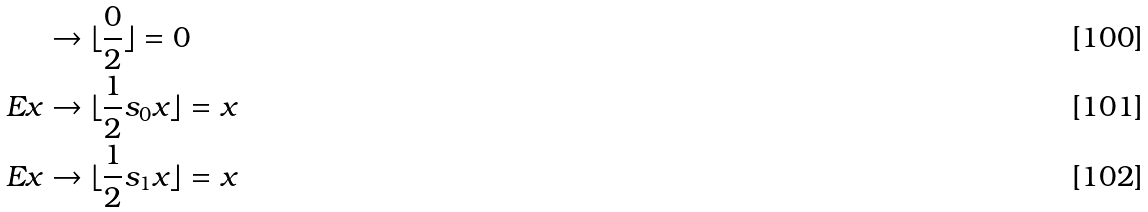Convert formula to latex. <formula><loc_0><loc_0><loc_500><loc_500>& \rightarrow \lfloor \frac { 0 } { 2 } \rfloor = 0 \\ E x & \rightarrow \lfloor \frac { 1 } { 2 } s _ { 0 } x \rfloor = x \\ E x & \rightarrow \lfloor \frac { 1 } { 2 } s _ { 1 } x \rfloor = x</formula> 